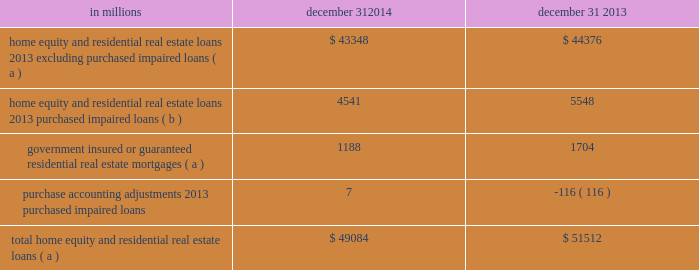Consumer lending asset classes home equity and residential real estate loan classes we use several credit quality indicators , including delinquency information , nonperforming loan information , updated credit scores , originated and updated ltv ratios , and geography , to monitor and manage credit risk within the home equity and residential real estate loan classes .
We evaluate mortgage loan performance by source originators and loan servicers .
A summary of asset quality indicators follows : delinquency/delinquency rates : we monitor trending of delinquency/delinquency rates for home equity and residential real estate loans .
See the asset quality section of this note 3 for additional information .
Nonperforming loans : we monitor trending of nonperforming loans for home equity and residential real estate loans .
See the asset quality section of this note 3 for additional information .
Credit scores : we use a national third-party provider to update fico credit scores for home equity loans and lines of credit and residential real estate loans at least quarterly .
The updated scores are incorporated into a series of credit management reports , which are utilized to monitor the risk in the loan classes .
Ltv ( inclusive of combined loan-to-value ( cltv ) for first and subordinate lien positions ) : at least annually , we update the property values of real estate collateral and calculate an updated ltv ratio .
For open-end credit lines secured by real estate in regions experiencing significant declines in property values , more frequent valuations may occur .
We examine ltv migration and stratify ltv into categories to monitor the risk in the loan classes .
Historically , we used , and we continue to use , a combination of original ltv and updated ltv for internal risk management and reporting purposes ( e.g. , line management , loss mitigation strategies ) .
In addition to the fact that estimated property values by their nature are estimates , given certain data limitations it is important to note that updated ltvs may be based upon management 2019s assumptions ( e.g. , if an updated ltv is not provided by the third-party service provider , home price index ( hpi ) changes will be incorporated in arriving at management 2019s estimate of updated ltv ) .
Geography : geographic concentrations are monitored to evaluate and manage exposures .
Loan purchase programs are sensitive to , and focused within , certain regions to manage geographic exposures and associated risks .
A combination of updated fico scores , originated and updated ltv ratios and geographic location assigned to home equity loans and lines of credit and residential real estate loans is used to monitor the risk in the loan classes .
Loans with higher fico scores and lower ltvs tend to have a lower level of risk .
Conversely , loans with lower fico scores , higher ltvs , and in certain geographic locations tend to have a higher level of risk .
Consumer purchased impaired loan class estimates of the expected cash flows primarily determine the valuation of consumer purchased impaired loans .
Consumer cash flow estimates are influenced by a number of credit related items , which include , but are not limited to : estimated real estate values , payment patterns , updated fico scores , the current economic environment , updated ltv ratios and the date of origination .
These key factors are monitored to help ensure that concentrations of risk are managed and cash flows are maximized .
See note 4 purchased loans for additional information .
Table 63 : home equity and residential real estate balances in millions december 31 december 31 .
( a ) represents recorded investment .
( b ) represents outstanding balance .
The pnc financial services group , inc .
2013 form 10-k 133 .
What is the total , in millions , that represents outstanding balances in 2013 and 2014? 
Computations: (4541 + 5548)
Answer: 10089.0. 